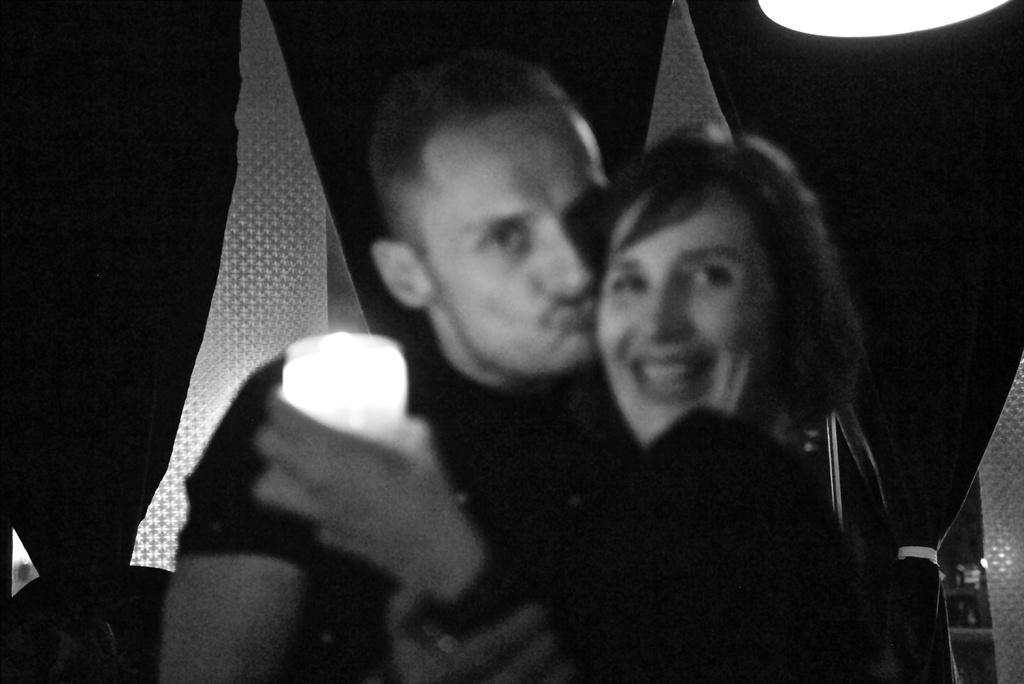In one or two sentences, can you explain what this image depicts? In front of the image there is a person kissing a woman and she is holding some object. Behind them there are flags. On top of the image there is a light. 